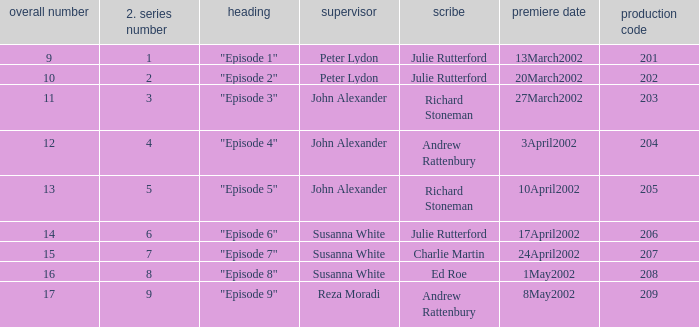When the title is "episode 1," what is the total number? 9.0. 